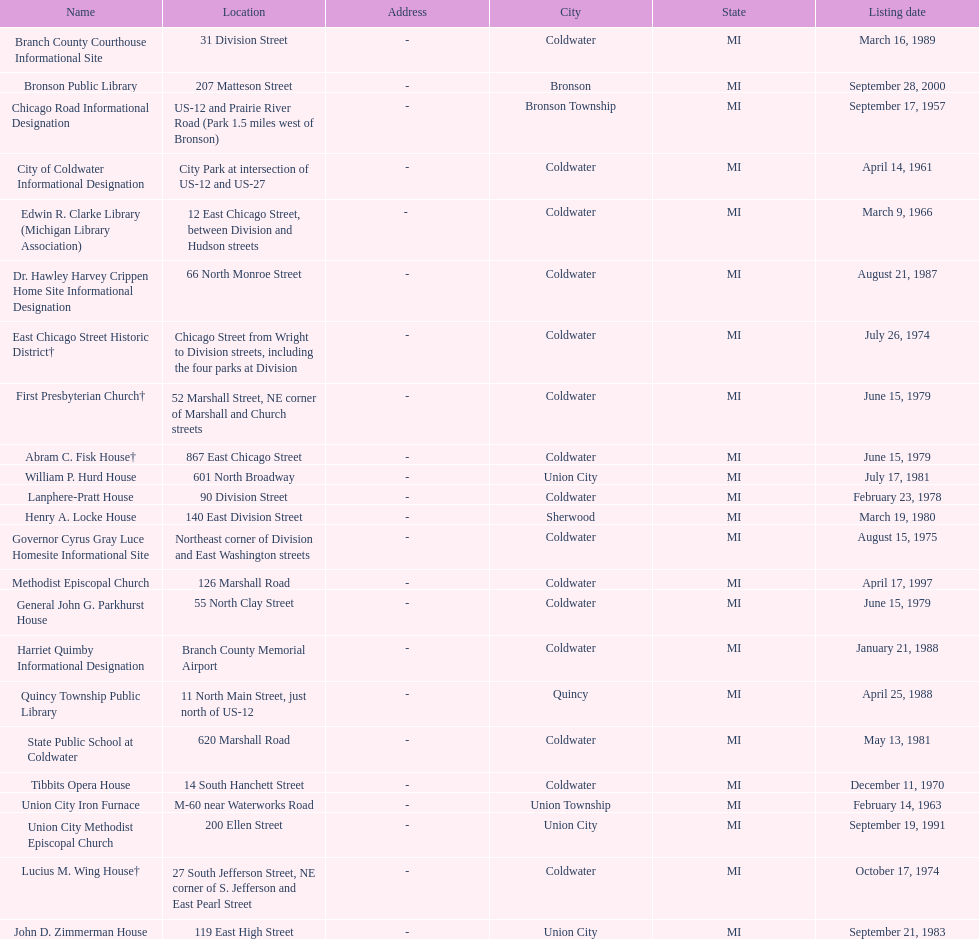How many years passed between the historic listing of public libraries in quincy and bronson? 12. 